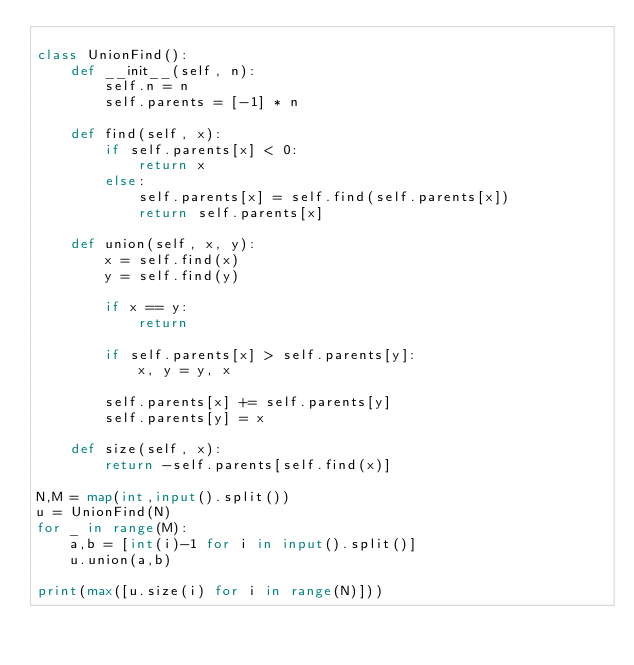Convert code to text. <code><loc_0><loc_0><loc_500><loc_500><_Python_>
class UnionFind():
    def __init__(self, n):
        self.n = n
        self.parents = [-1] * n

    def find(self, x):
        if self.parents[x] < 0:
            return x
        else:
            self.parents[x] = self.find(self.parents[x])
            return self.parents[x]

    def union(self, x, y):
        x = self.find(x)
        y = self.find(y)

        if x == y:
            return

        if self.parents[x] > self.parents[y]:
            x, y = y, x

        self.parents[x] += self.parents[y]
        self.parents[y] = x

    def size(self, x):
        return -self.parents[self.find(x)]

N,M = map(int,input().split())
u = UnionFind(N)
for _ in range(M):
    a,b = [int(i)-1 for i in input().split()]
    u.union(a,b)

print(max([u.size(i) for i in range(N)]))</code> 